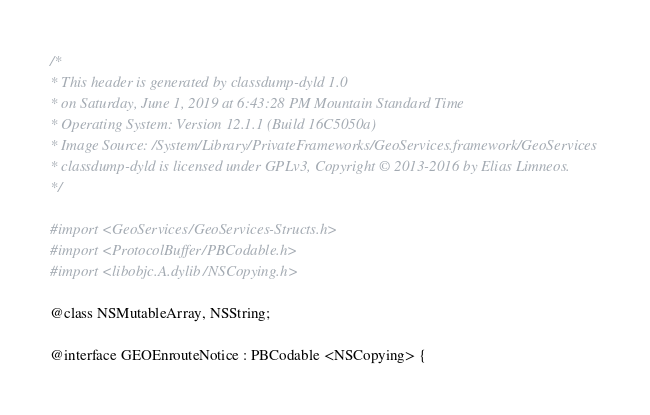Convert code to text. <code><loc_0><loc_0><loc_500><loc_500><_C_>/*
* This header is generated by classdump-dyld 1.0
* on Saturday, June 1, 2019 at 6:43:28 PM Mountain Standard Time
* Operating System: Version 12.1.1 (Build 16C5050a)
* Image Source: /System/Library/PrivateFrameworks/GeoServices.framework/GeoServices
* classdump-dyld is licensed under GPLv3, Copyright © 2013-2016 by Elias Limneos.
*/

#import <GeoServices/GeoServices-Structs.h>
#import <ProtocolBuffer/PBCodable.h>
#import <libobjc.A.dylib/NSCopying.h>

@class NSMutableArray, NSString;

@interface GEOEnrouteNotice : PBCodable <NSCopying> {
</code> 